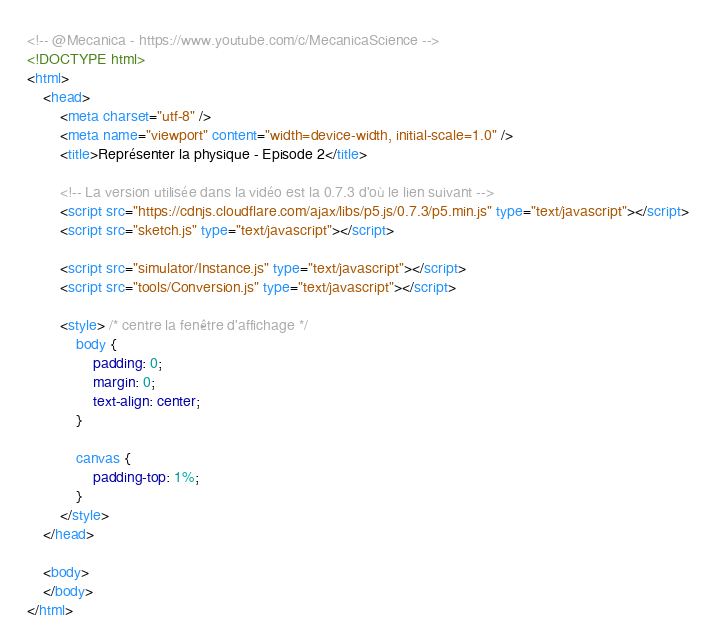Convert code to text. <code><loc_0><loc_0><loc_500><loc_500><_HTML_><!-- @Mecanica - https://www.youtube.com/c/MecanicaScience -->
<!DOCTYPE html>
<html>
	<head>
		<meta charset="utf-8" />
		<meta name="viewport" content="width=device-width, initial-scale=1.0" />
		<title>Représenter la physique - Episode 2</title>

		<!-- La version utilisée dans la vidéo est la 0.7.3 d'où le lien suivant -->
		<script src="https://cdnjs.cloudflare.com/ajax/libs/p5.js/0.7.3/p5.min.js" type="text/javascript"></script>
		<script src="sketch.js" type="text/javascript"></script>

		<script src="simulator/Instance.js" type="text/javascript"></script>
		<script src="tools/Conversion.js" type="text/javascript"></script>

		<style> /* centre la fenêtre d'affichage */
			body {
				padding: 0;
				margin: 0;
				text-align: center;
			}

			canvas {
				padding-top: 1%;
			}
		</style>
	</head>

	<body>
	</body>
</html>
</code> 